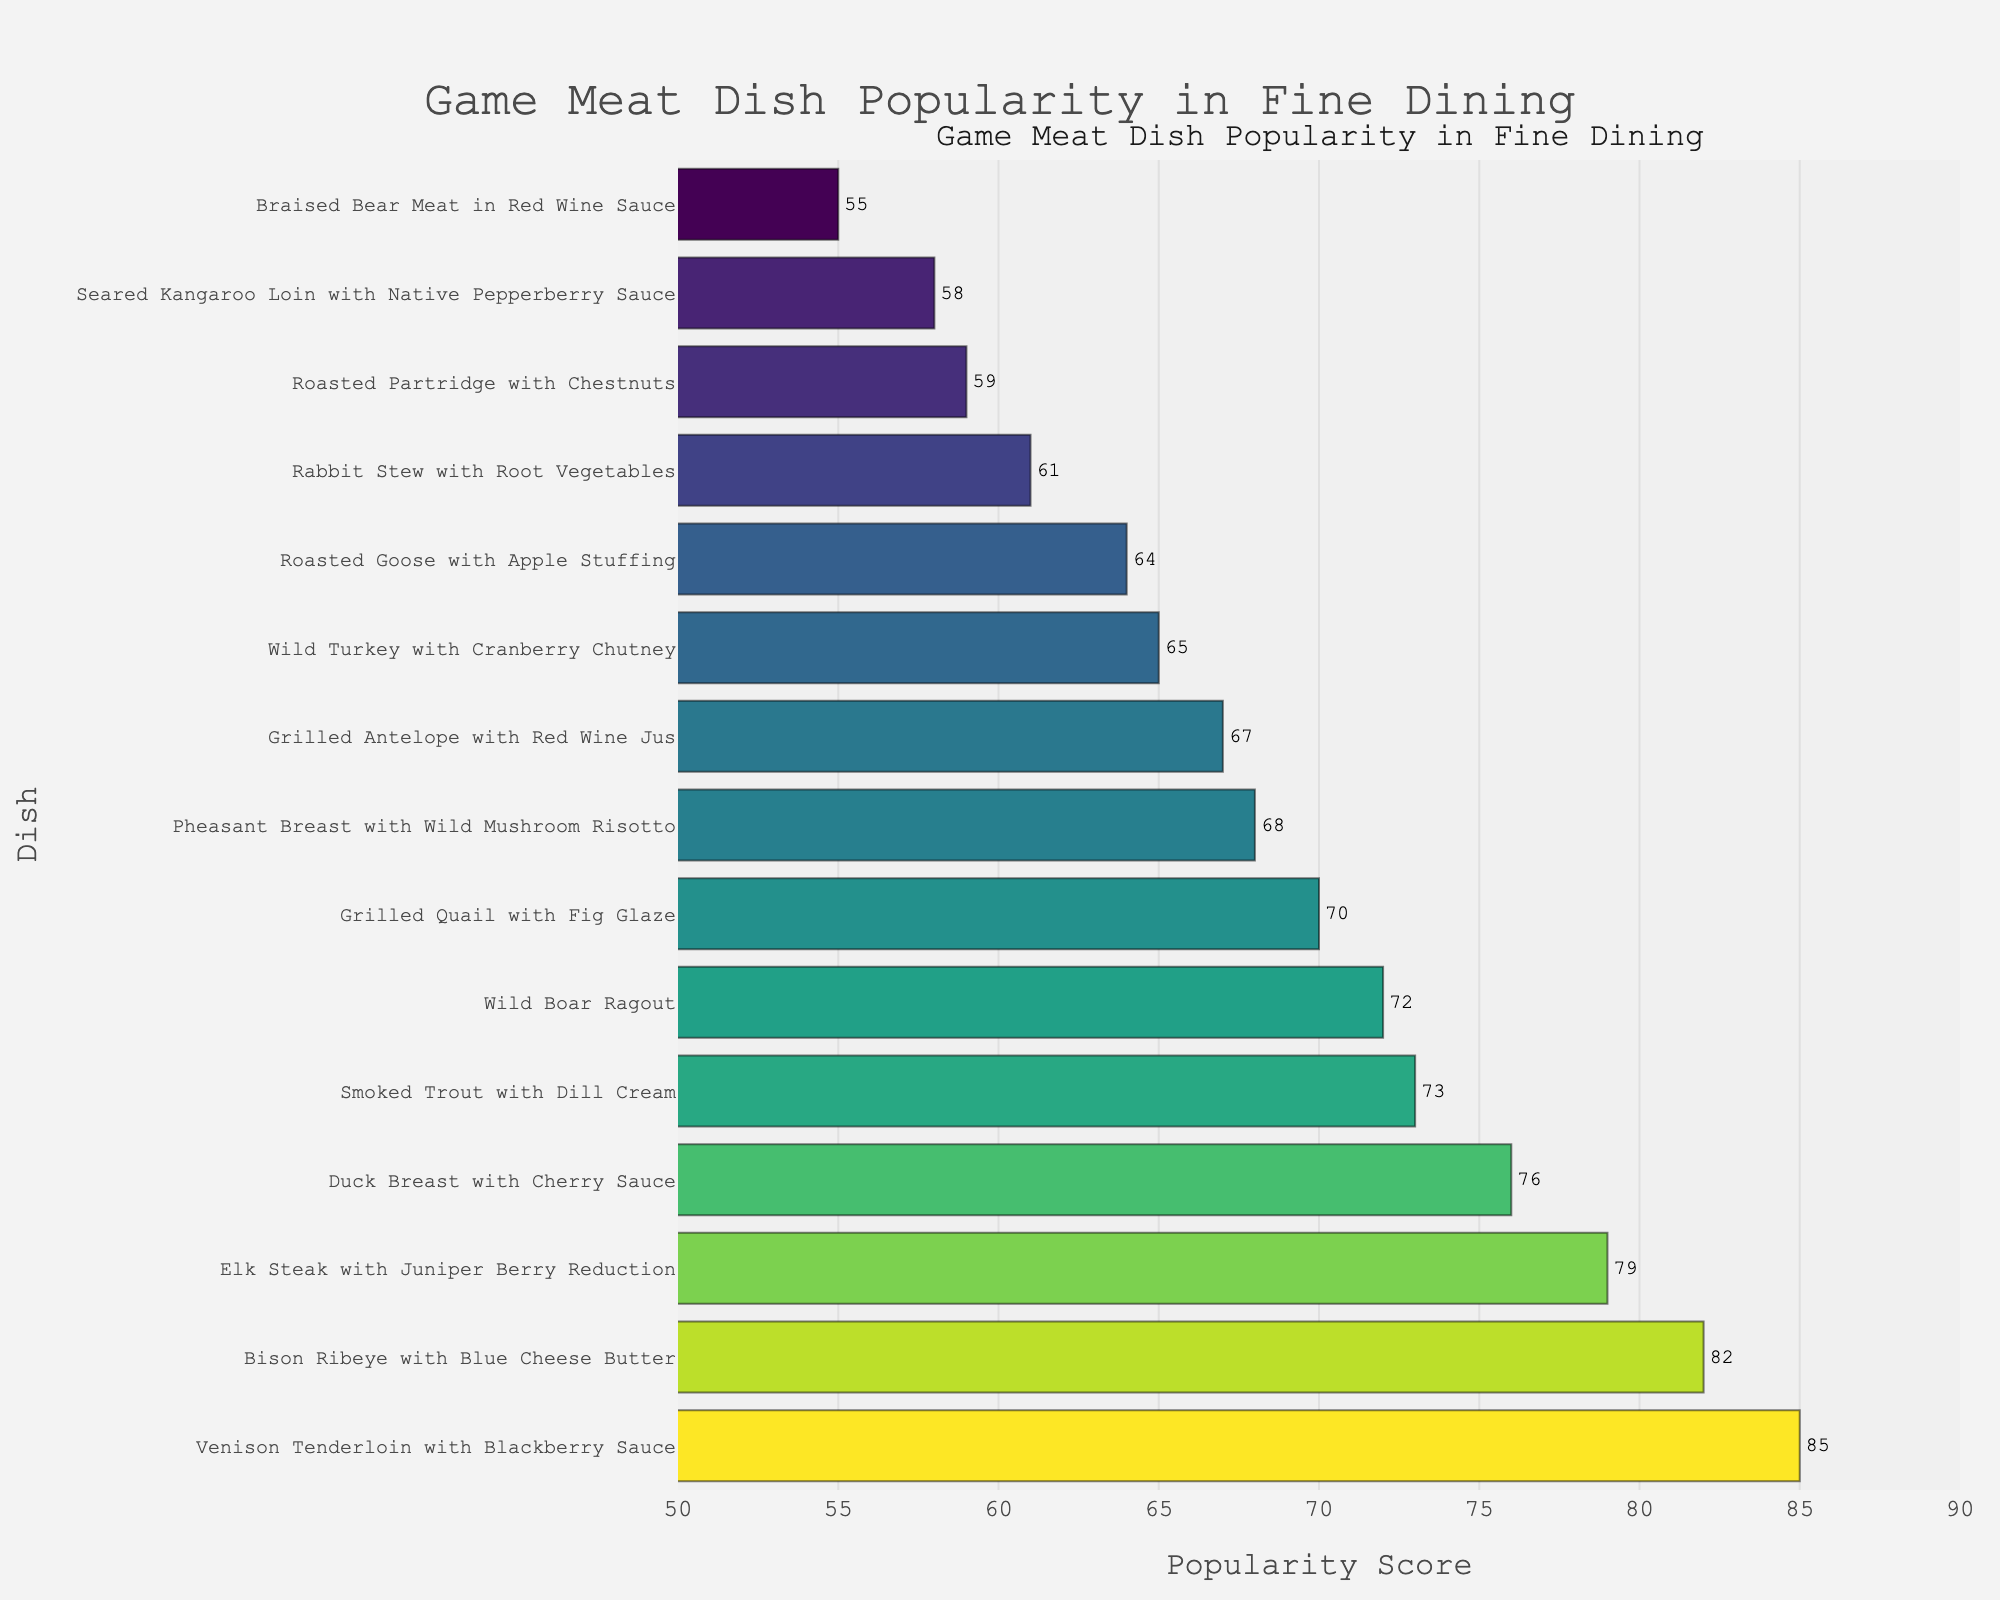What is the most popular game meat dish in fine dining restaurants? The most popular dish will have the highest bar in the chart. By observing the chart, the highest bar corresponds to "Venison Tenderloin with Blackberry Sauce" with a score of 85.
Answer: Venison Tenderloin with Blackberry Sauce Which game meat dish has the highest popularity score among Pheasant Breast with Wild Mushroom Risotto and Grilled Quail with Fig Glaze? Compare the score of "Pheasant Breast with Wild Mushroom Risotto" (68) to that of "Grilled Quail with Fig Glaze" (70). The latter has a higher score.
Answer: Grilled Quail with Fig Glaze What is the difference in popularity score between the Bison Ribeye with Blue Cheese Butter and Braised Bear Meat in Red Wine Sauce? Subtract the score of the Braised Bear Meat in Red Wine Sauce (55) from the Bison Ribeye with Blue Cheese Butter (82) to find the difference. 82 - 55 = 27
Answer: 27 How many game meat dishes have a popularity score greater than 70? Count all the dishes in the chart with a score greater than 70: Venison Tenderloin with Blackberry Sauce (85), Elk Steak with Juniper Berry Reduction (79), Duck Breast with Cherry Sauce (76), Smoked Trout with Dill Cream (73), and Bison Ribeye with Blue Cheese Butter (82).
Answer: 5 What is the average popularity score of the top three most popular dishes? Identify the top three dishes based on their scores: Venison Tenderloin with Blackberry Sauce (85), Bison Ribeye with Blue Cheese Butter (82), and Elk Steak with Juniper Berry Reduction (79). Calculate the average: (85 + 82 + 79) / 3 = 82.
Answer: 82 Among the dishes with scores below 60, which one has the highest popularity score? Identify dishes with scores below 60: Roasted Partridge with Chestnuts (59), Seared Kangaroo Loin with Native Pepperberry Sauce (58), Braised Bear Meat in Red Wine Sauce (55). Compare their scores to find the highest one, which is Roasted Partridge with Chestnuts (59).
Answer: Roasted Partridge with Chestnuts Which dish has the lowest popularity score? The dish with the smallest bar in the chart will have the lowest score. By observing the chart, the lowest bar corresponds to "Braised Bear Meat in Red Wine Sauce" with a score of 55.
Answer: Braised Bear Meat in Red Wine Sauce What is the sum of the popularity scores for Wild Boar Ragout and Rabbit Stew with Root Vegetables? Add the scores of both dishes: Wild Boar Ragout (72) + Rabbit Stew with Root Vegetables (61) = 133.
Answer: 133 Is the popularity score of Seared Kangaroo Loin with Native Pepperberry Sauce higher or lower than a Smoked Trout with Dill Cream? Compare the scores: Seared Kangaroo Loin with Native Pepperberry Sauce (58) and Smoked Trout with Dill Cream (73). The Smoked Trout with Dill Cream has a higher score.
Answer: Lower 